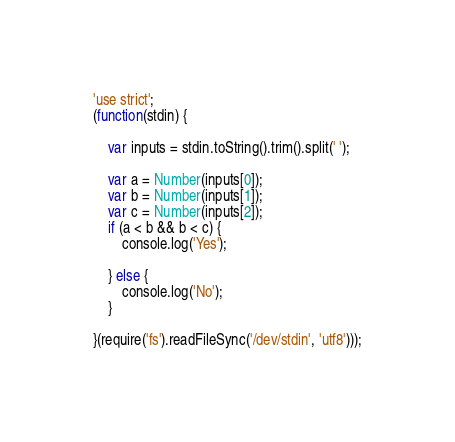Convert code to text. <code><loc_0><loc_0><loc_500><loc_500><_JavaScript_>'use strict';
(function(stdin) {

    var inputs = stdin.toString().trim().split(' ');

    var a = Number(inputs[0]);
    var b = Number(inputs[1]);
    var c = Number(inputs[2]);
    if (a < b && b < c) {
        console.log('Yes');

    } else {
        console.log('No');
    }

}(require('fs').readFileSync('/dev/stdin', 'utf8')));</code> 